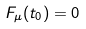<formula> <loc_0><loc_0><loc_500><loc_500>F _ { \mu } ( t _ { 0 } ) = 0</formula> 